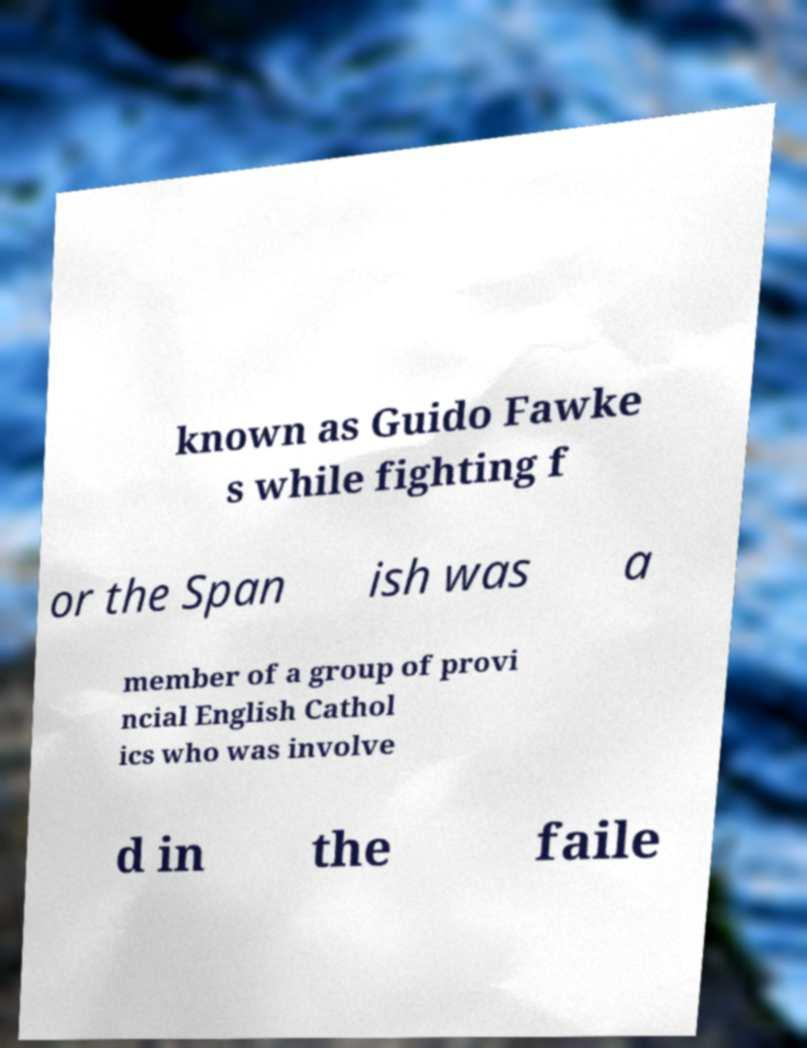Could you assist in decoding the text presented in this image and type it out clearly? known as Guido Fawke s while fighting f or the Span ish was a member of a group of provi ncial English Cathol ics who was involve d in the faile 